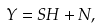Convert formula to latex. <formula><loc_0><loc_0><loc_500><loc_500>Y = S H + N ,</formula> 